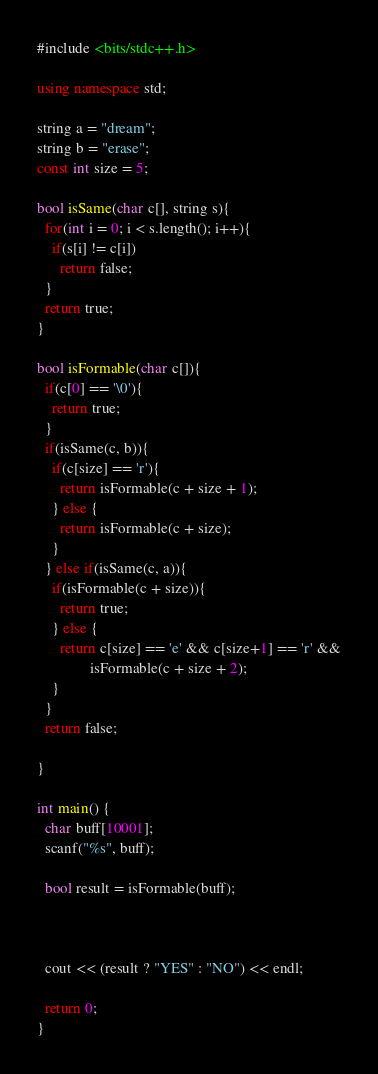Convert code to text. <code><loc_0><loc_0><loc_500><loc_500><_C++_>#include <bits/stdc++.h>

using namespace std;

string a = "dream";
string b = "erase";
const int size = 5;

bool isSame(char c[], string s){
  for(int i = 0; i < s.length(); i++){
    if(s[i] != c[i])
      return false;
  }
  return true;
}

bool isFormable(char c[]){
  if(c[0] == '\0'){
    return true;
  }
  if(isSame(c, b)){
    if(c[size] == 'r'){
      return isFormable(c + size + 1);
    } else {
      return isFormable(c + size);
    }
  } else if(isSame(c, a)){
    if(isFormable(c + size)){
      return true;
    } else {
      return c[size] == 'e' && c[size+1] == 'r' &&
              isFormable(c + size + 2);
    }
  }
  return false;

}

int main() {
  char buff[10001];
  scanf("%s", buff);

  bool result = isFormable(buff);



  cout << (result ? "YES" : "NO") << endl;

  return 0;
}</code> 